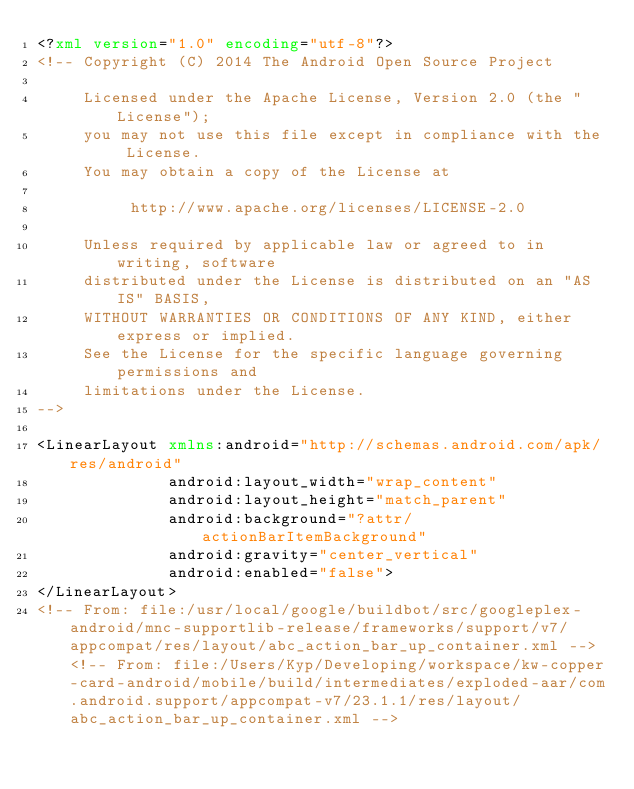Convert code to text. <code><loc_0><loc_0><loc_500><loc_500><_XML_><?xml version="1.0" encoding="utf-8"?>
<!-- Copyright (C) 2014 The Android Open Source Project

     Licensed under the Apache License, Version 2.0 (the "License");
     you may not use this file except in compliance with the License.
     You may obtain a copy of the License at

          http://www.apache.org/licenses/LICENSE-2.0

     Unless required by applicable law or agreed to in writing, software
     distributed under the License is distributed on an "AS IS" BASIS,
     WITHOUT WARRANTIES OR CONDITIONS OF ANY KIND, either express or implied.
     See the License for the specific language governing permissions and
     limitations under the License.
-->

<LinearLayout xmlns:android="http://schemas.android.com/apk/res/android"
              android:layout_width="wrap_content"
              android:layout_height="match_parent"
              android:background="?attr/actionBarItemBackground"
              android:gravity="center_vertical"
              android:enabled="false">
</LinearLayout>
<!-- From: file:/usr/local/google/buildbot/src/googleplex-android/mnc-supportlib-release/frameworks/support/v7/appcompat/res/layout/abc_action_bar_up_container.xml --><!-- From: file:/Users/Kyp/Developing/workspace/kw-copper-card-android/mobile/build/intermediates/exploded-aar/com.android.support/appcompat-v7/23.1.1/res/layout/abc_action_bar_up_container.xml --></code> 